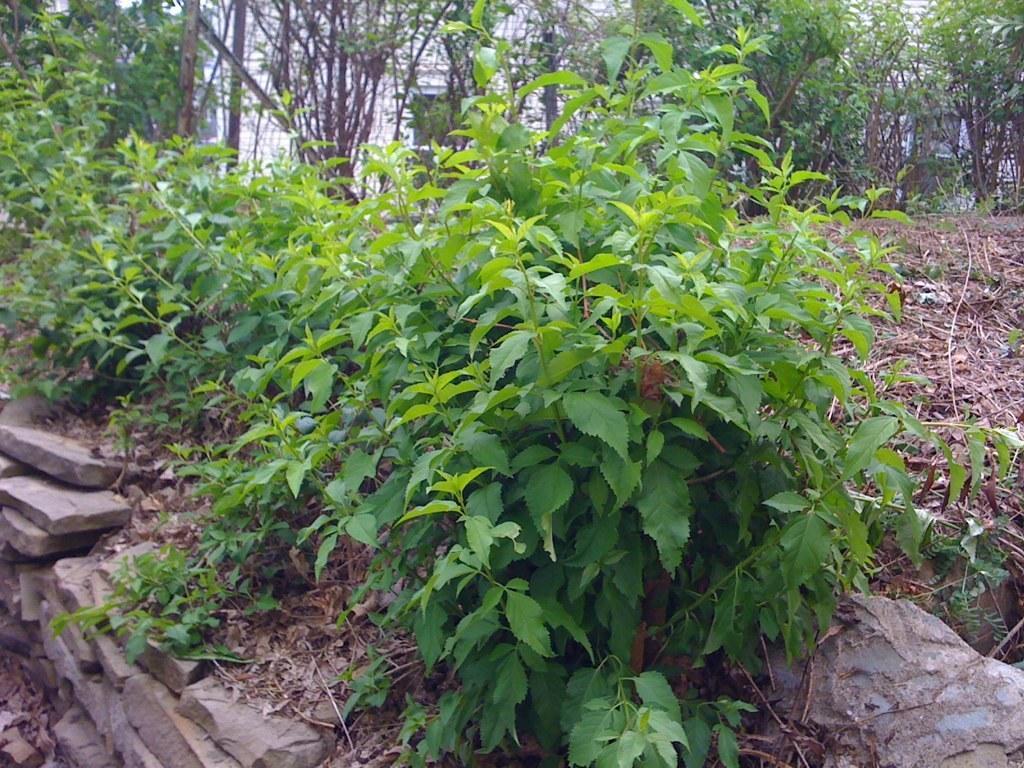Could you give a brief overview of what you see in this image? There are plants on the ground near stone's wall. In the background, there are trees and there is a white color building. 